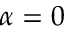<formula> <loc_0><loc_0><loc_500><loc_500>\alpha = 0</formula> 